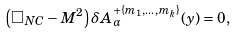Convert formula to latex. <formula><loc_0><loc_0><loc_500><loc_500>\left ( \Box _ { N C } - M ^ { 2 } \right ) \delta A ^ { + \{ m _ { 1 } , \dots , m _ { k } \} } _ { \alpha } ( y ) = 0 ,</formula> 